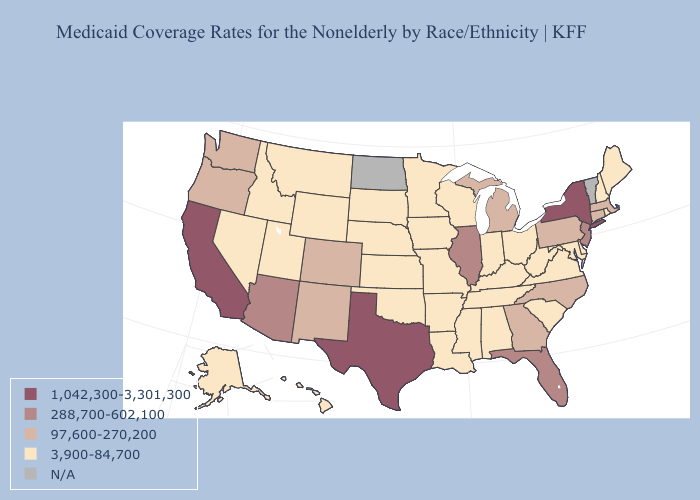Does the map have missing data?
Be succinct. Yes. Does the map have missing data?
Be succinct. Yes. Among the states that border Arkansas , does Oklahoma have the highest value?
Quick response, please. No. Name the states that have a value in the range 1,042,300-3,301,300?
Quick response, please. California, New York, Texas. What is the value of Maine?
Short answer required. 3,900-84,700. Name the states that have a value in the range 97,600-270,200?
Write a very short answer. Colorado, Connecticut, Georgia, Massachusetts, Michigan, New Mexico, North Carolina, Oregon, Pennsylvania, Washington. Which states have the highest value in the USA?
Be succinct. California, New York, Texas. What is the value of New York?
Be succinct. 1,042,300-3,301,300. What is the value of Arizona?
Short answer required. 288,700-602,100. Name the states that have a value in the range 97,600-270,200?
Quick response, please. Colorado, Connecticut, Georgia, Massachusetts, Michigan, New Mexico, North Carolina, Oregon, Pennsylvania, Washington. Among the states that border Pennsylvania , which have the highest value?
Short answer required. New York. What is the highest value in the USA?
Quick response, please. 1,042,300-3,301,300. Does Arkansas have the lowest value in the South?
Be succinct. Yes. 